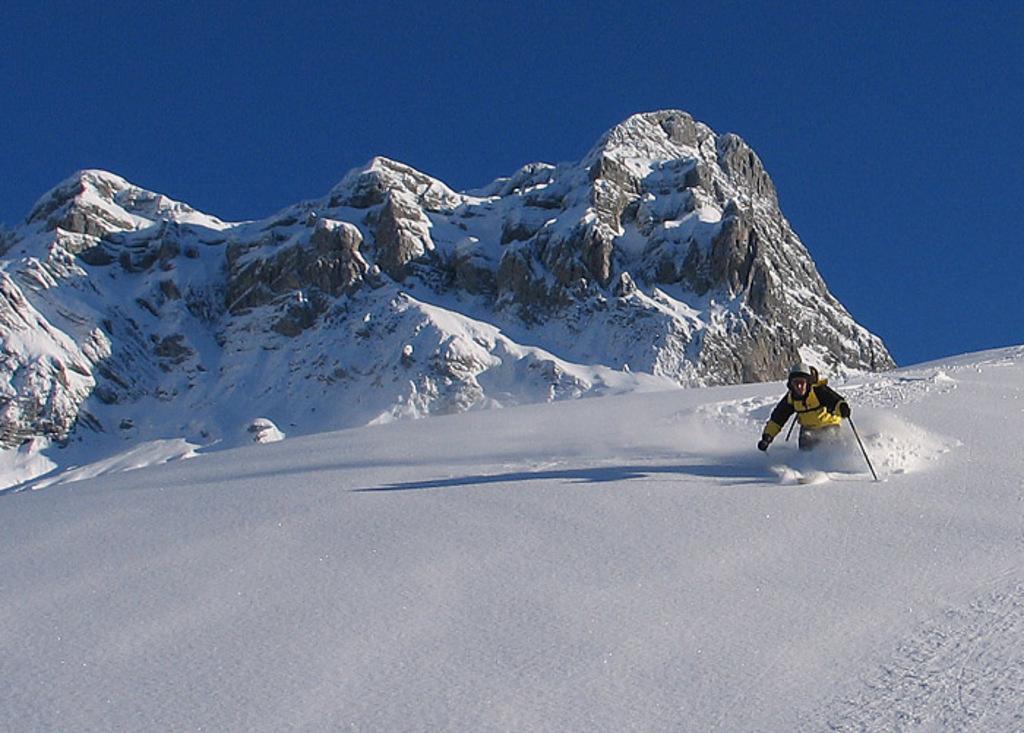Please provide a concise description of this image. In this image, we can see a person wearing clothes and holding a stick with his hand. There is a mountain in the middle of the image. There is a sky at the top of the image. 